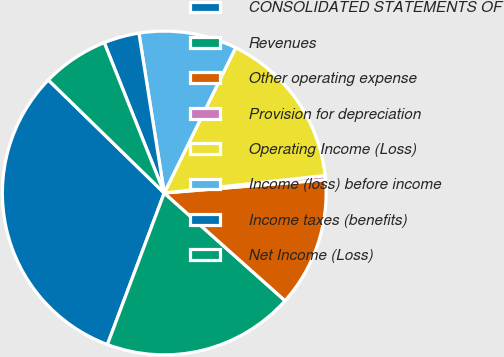Convert chart to OTSL. <chart><loc_0><loc_0><loc_500><loc_500><pie_chart><fcel>CONSOLIDATED STATEMENTS OF<fcel>Revenues<fcel>Other operating expense<fcel>Provision for depreciation<fcel>Operating Income (Loss)<fcel>Income (loss) before income<fcel>Income taxes (benefits)<fcel>Net Income (Loss)<nl><fcel>31.59%<fcel>19.12%<fcel>12.89%<fcel>0.42%<fcel>16.01%<fcel>9.77%<fcel>3.54%<fcel>6.66%<nl></chart> 